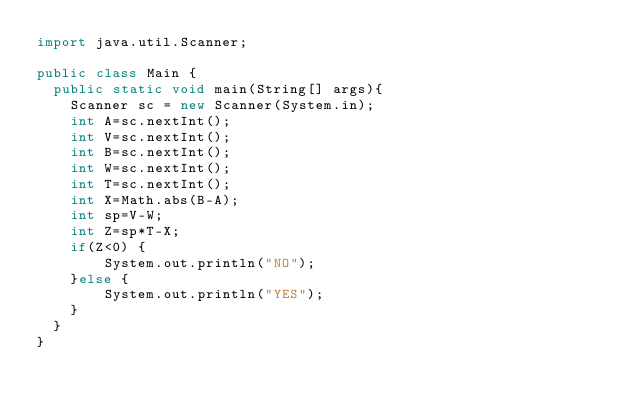<code> <loc_0><loc_0><loc_500><loc_500><_Java_>import java.util.Scanner;
 
public class Main {
  public static void main(String[] args){
    Scanner sc = new Scanner(System.in);
    int A=sc.nextInt();
    int V=sc.nextInt();
    int B=sc.nextInt();
    int W=sc.nextInt();
    int T=sc.nextInt();
    int X=Math.abs(B-A);
    int sp=V-W;
    int Z=sp*T-X;
    if(Z<0) {
    	System.out.println("NO");
    }else {
    	System.out.println("YES");
    }
  }
}
  </code> 